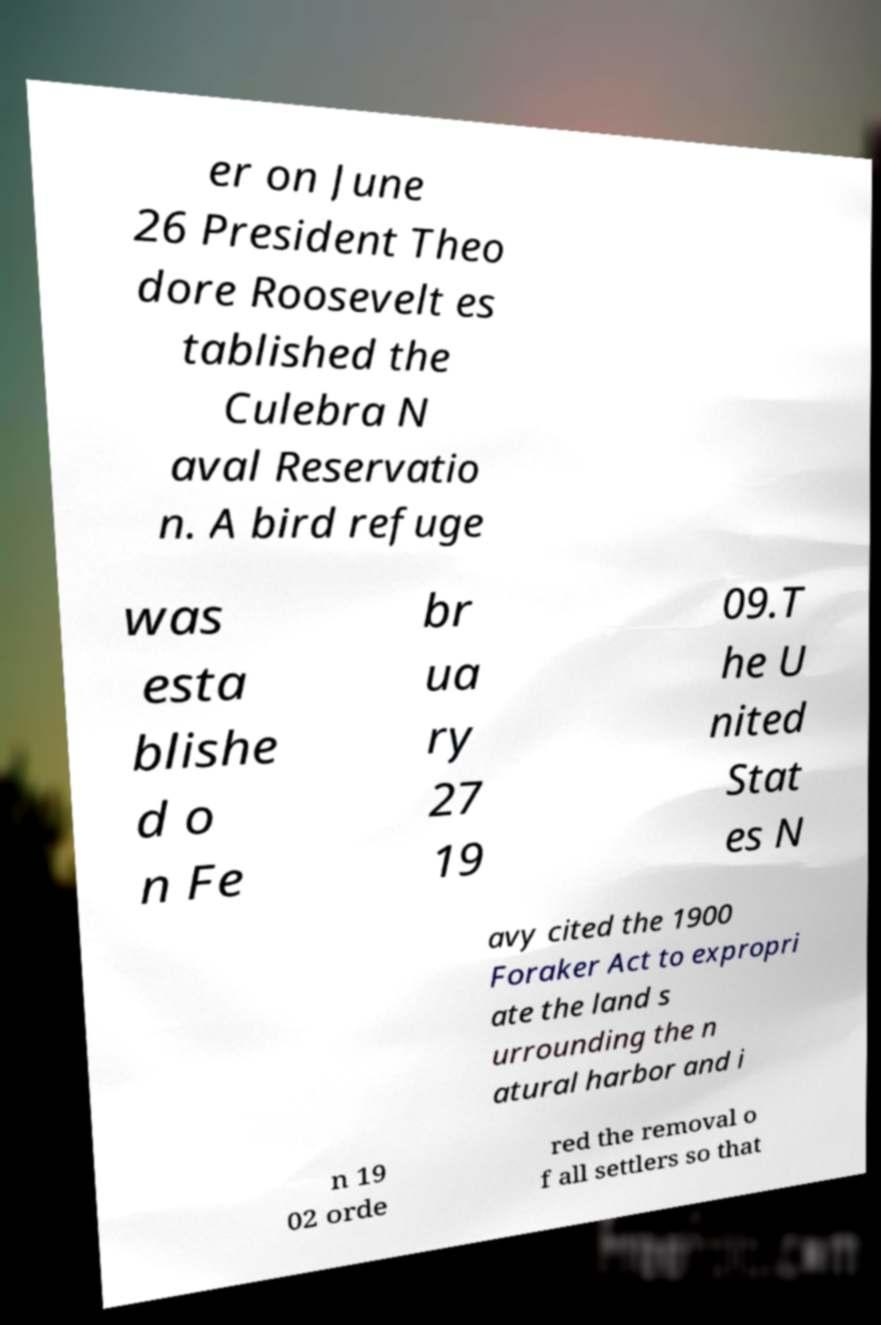Please read and relay the text visible in this image. What does it say? er on June 26 President Theo dore Roosevelt es tablished the Culebra N aval Reservatio n. A bird refuge was esta blishe d o n Fe br ua ry 27 19 09.T he U nited Stat es N avy cited the 1900 Foraker Act to expropri ate the land s urrounding the n atural harbor and i n 19 02 orde red the removal o f all settlers so that 